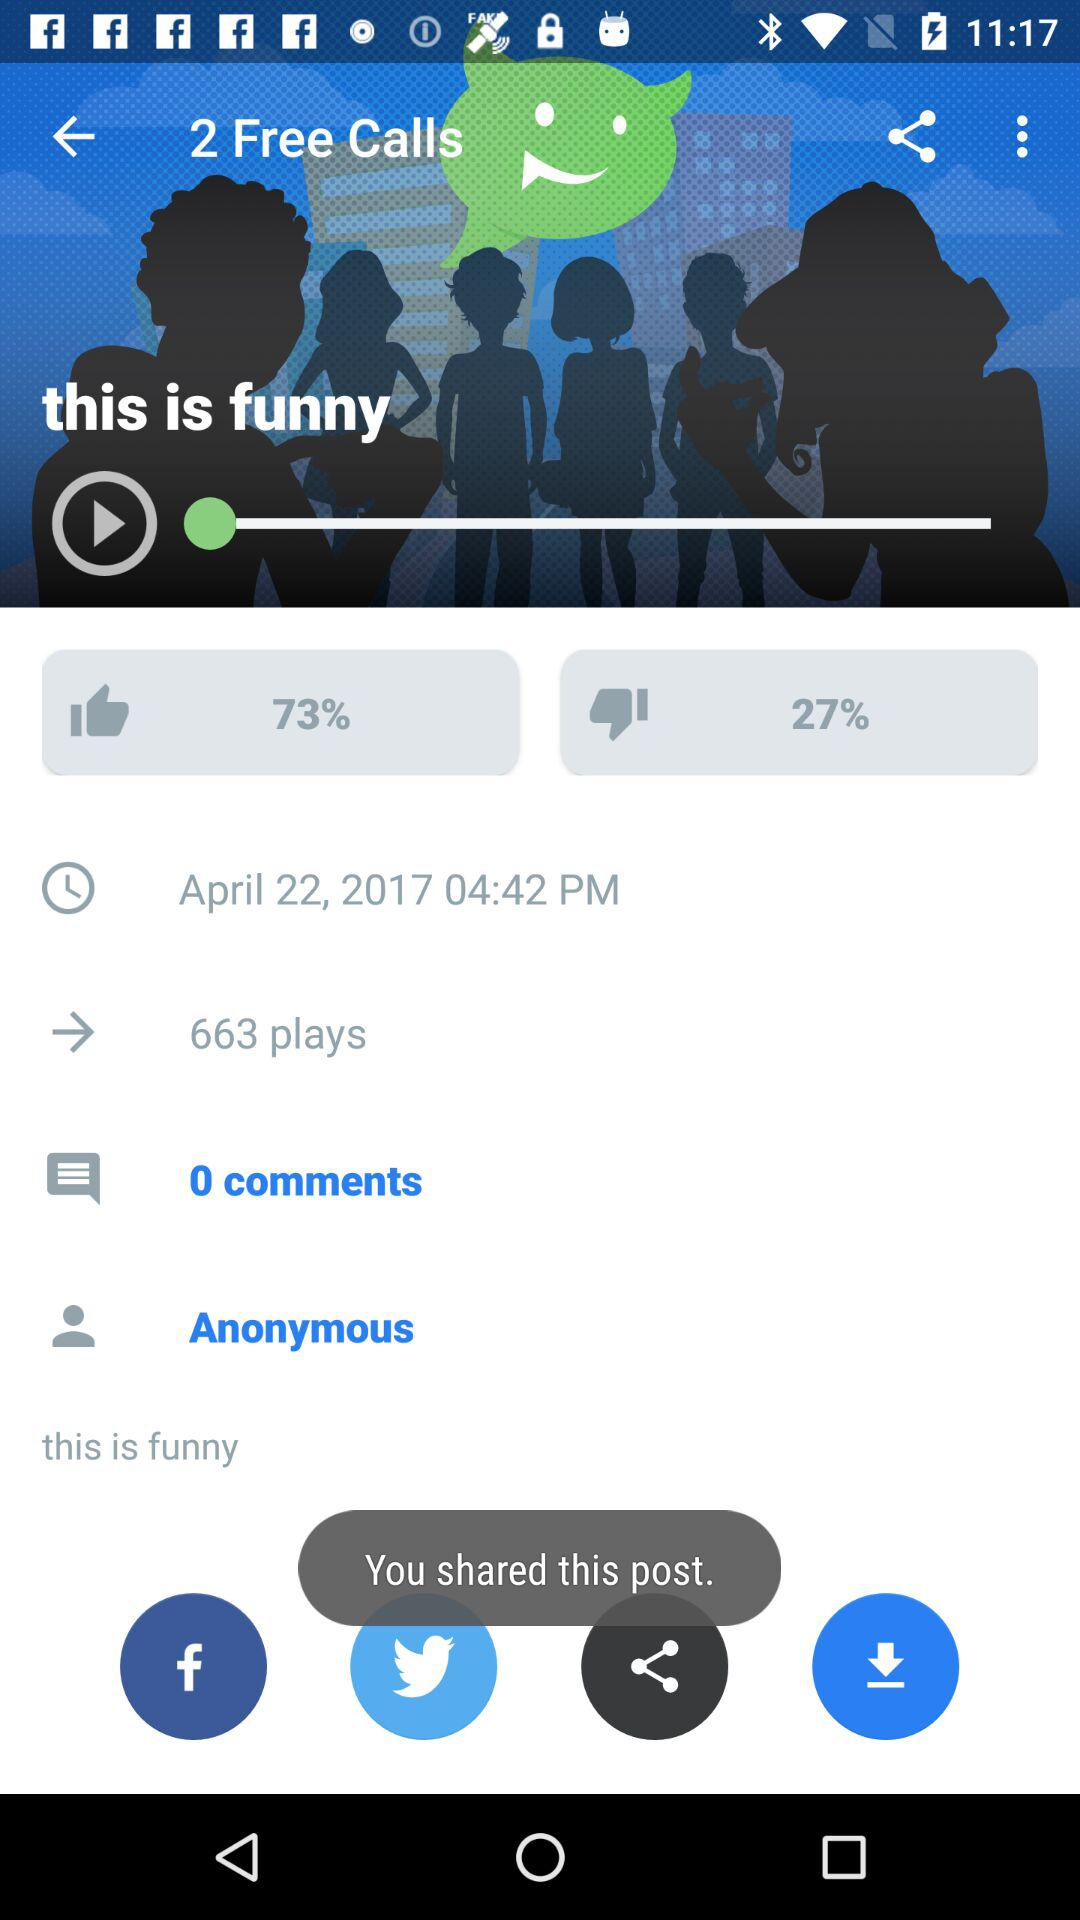What is the difference between the number of plays and comments?
Answer the question using a single word or phrase. 663 